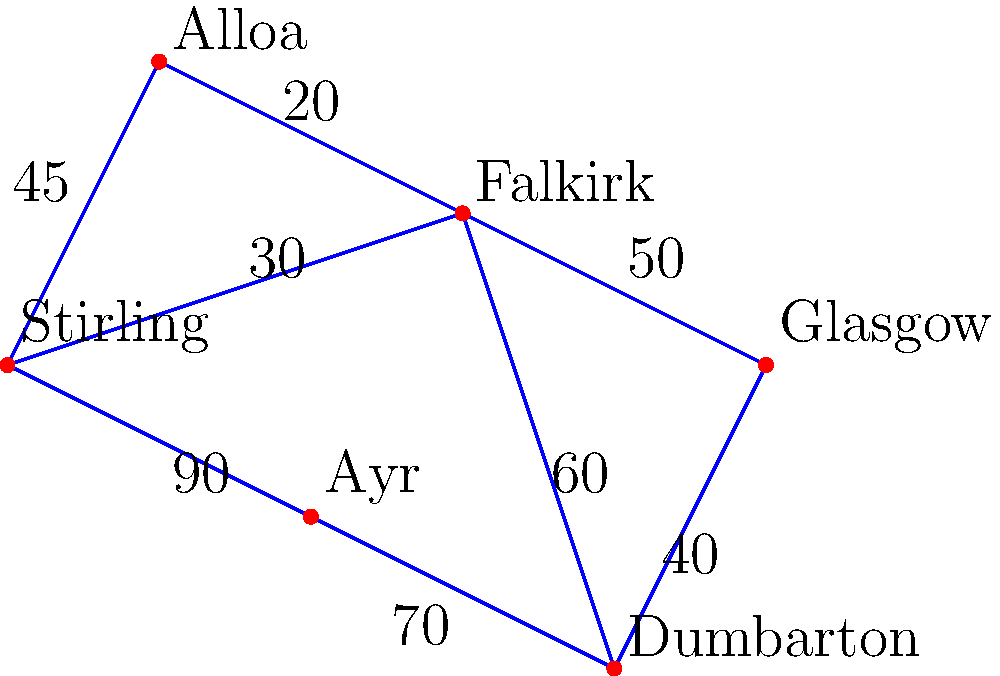As a long-time Stirling Albion fan, you're planning away trips for the season. Given the map of distances (in minutes) between Stirling and other football grounds, what's the shortest travel time from Stirling to Glasgow? To find the shortest path from Stirling to Glasgow, we'll use Dijkstra's algorithm:

1. Start at Stirling (0 minutes)
2. Examine neighbors:
   - Stirling to Alloa: 45 minutes
   - Stirling to Falkirk: 30 minutes
   - Stirling to Ayr: 90 minutes
3. Choose Falkirk (30 minutes)
4. From Falkirk, examine:
   - Falkirk to Alloa: 30 + 20 = 50 minutes
   - Falkirk to Dumbarton: 30 + 60 = 90 minutes
   - Falkirk to Glasgow: 30 + 50 = 80 minutes
5. Choose Glasgow (80 minutes)

The shortest path is Stirling → Falkirk → Glasgow, taking 80 minutes.
Answer: 80 minutes 